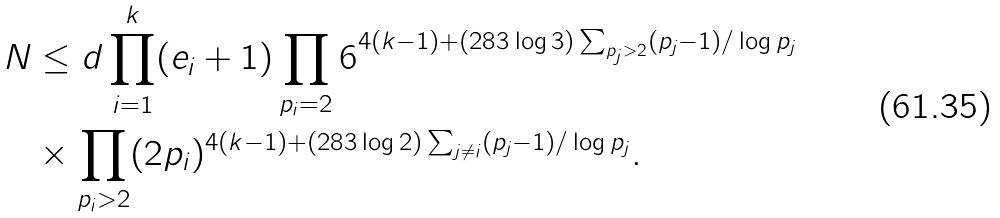<formula> <loc_0><loc_0><loc_500><loc_500>N & \leq d \prod _ { i = 1 } ^ { k } ( e _ { i } + 1 ) \prod _ { p _ { i } = 2 } 6 ^ { 4 ( k - 1 ) + ( 2 8 3 \log 3 ) \sum _ { p _ { j } > 2 } ( p _ { j } - 1 ) / \log p _ { j } } \\ & \times \prod _ { p _ { i } > 2 } ( 2 p _ { i } ) ^ { 4 ( k - 1 ) + ( 2 8 3 \log 2 ) \sum _ { j \neq i } ( p _ { j } - 1 ) / \log p _ { j } } .</formula> 